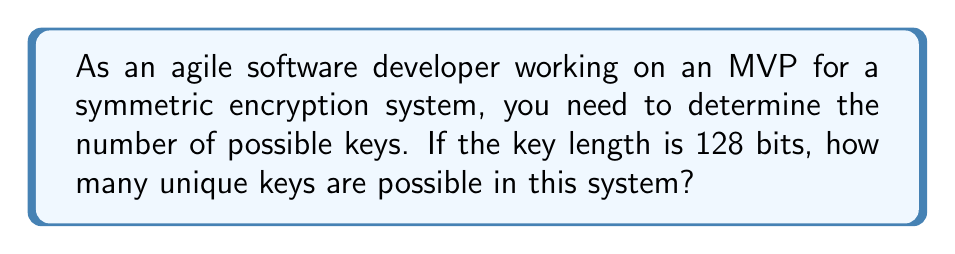Provide a solution to this math problem. To determine the number of possible keys in a symmetric encryption system with a key length of 128 bits, we need to follow these steps:

1. Understand that each bit in the key can have two possible values: 0 or 1.

2. For a single bit, we have 2 possibilities.

3. For two bits, we have $2 \times 2 = 2^2 = 4$ possibilities.

4. For three bits, we have $2 \times 2 \times 2 = 2^3 = 8$ possibilities.

5. Following this pattern, for 128 bits, we have:

   $$2^{128}$$

6. Calculate the result:
   
   $2^{128} = 340,282,366,920,938,463,463,374,607,431,768,211,456$

This extremely large number represents the total number of possible unique keys in a 128-bit symmetric encryption system. 

In the context of MVP development, this level of security is generally considered sufficient for most applications, as it would be computationally infeasible to brute-force all possible keys in a reasonable timeframe with current technology.
Answer: $2^{128}$ 